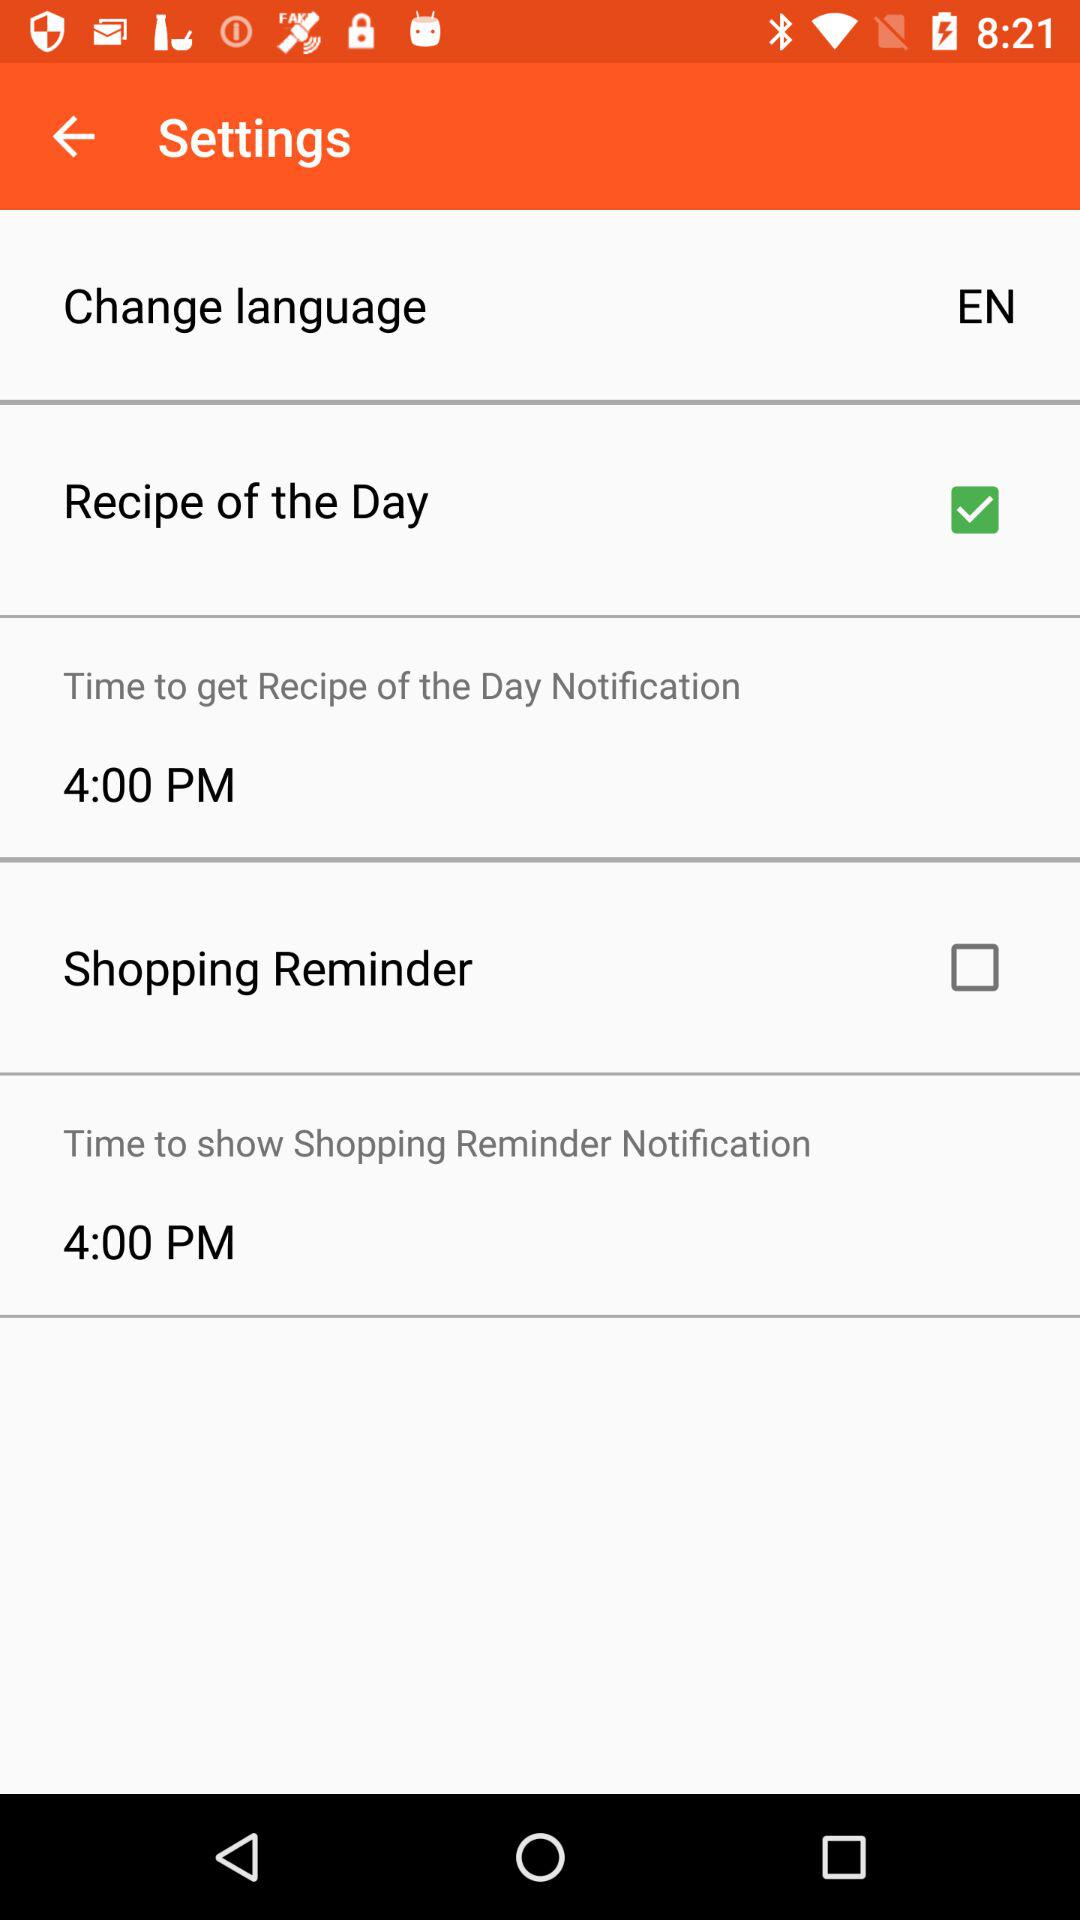What is the status of the "Shopping Reminder"? The status of the "Shopping Reminder" is "off". 